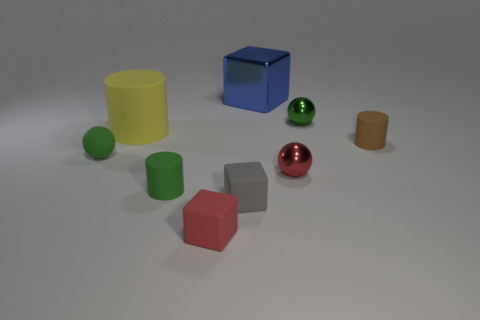There is another ball that is the same color as the small rubber sphere; what is its size?
Provide a short and direct response. Small. Is the number of metallic blocks behind the tiny green rubber sphere greater than the number of large gray metallic cubes?
Your response must be concise. Yes. Is there a small metallic thing of the same color as the small matte ball?
Offer a very short reply. Yes. There is a matte cylinder that is the same size as the brown matte thing; what color is it?
Offer a very short reply. Green. How many things are in front of the tiny shiny ball behind the small rubber sphere?
Give a very brief answer. 7. How many things are matte cylinders behind the tiny brown rubber cylinder or green rubber things?
Your response must be concise. 3. What number of spheres are made of the same material as the yellow object?
Provide a succinct answer. 1. What is the shape of the metallic object that is the same color as the tiny rubber sphere?
Keep it short and to the point. Sphere. Are there an equal number of gray matte objects that are behind the blue object and small green cylinders?
Keep it short and to the point. No. There is a green ball on the left side of the red matte block; what is its size?
Provide a succinct answer. Small. 